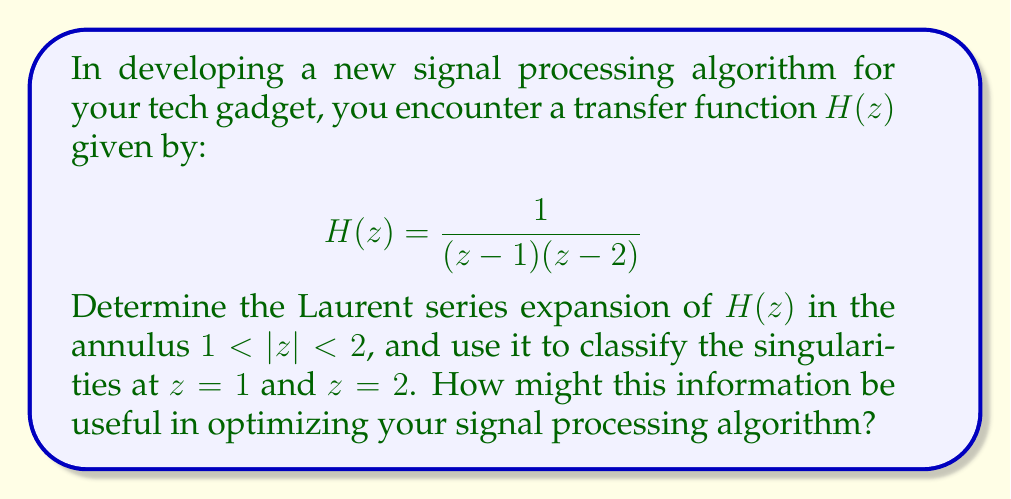Solve this math problem. To solve this problem, we'll follow these steps:

1) First, we need to find the partial fraction decomposition of $H(z)$:

   $$H(z) = \frac{1}{(z-1)(z-2)} = \frac{A}{z-1} + \frac{B}{z-2}$$

   Solving for A and B:
   
   $$A = \lim_{z \to 1} (z-1)H(z) = \frac{1}{1-2} = -1$$
   $$B = \lim_{z \to 2} (z-2)H(z) = \frac{1}{2-1} = 1$$

   So, $H(z) = -\frac{1}{z-1} + \frac{1}{z-2}$

2) Now, we need to expand each term in a Laurent series valid in $1 < |z| < 2$:

   For $-\frac{1}{z-1}$:
   $$-\frac{1}{z-1} = -\frac{1}{z} \cdot \frac{1}{1-\frac{1}{z}} = -\frac{1}{z}(1 + \frac{1}{z} + \frac{1}{z^2} + ...)$$
   $$= -\frac{1}{z} - \frac{1}{z^2} - \frac{1}{z^3} - ...$$

   For $\frac{1}{z-2}$:
   $$\frac{1}{z-2} = -\frac{1}{2} \cdot \frac{1}{1-\frac{z}{2}} = -\frac{1}{2}(1 + \frac{z}{2} + (\frac{z}{2})^2 + ...)$$
   $$= -\frac{1}{2} - \frac{z}{4} - \frac{z^2}{8} - ...$$

3) Combining these series:

   $$H(z) = (-\frac{1}{z} - \frac{1}{z^2} - \frac{1}{z^3} - ...) + (-\frac{1}{2} - \frac{z}{4} - \frac{z^2}{8} - ...)$$

4) Classifying the singularities:

   At $z=1$: The series has negative powers of $z$, indicating a pole.
   At $z=2$: The series has only positive powers of $z$, indicating a removable singularity.

5) Relevance to signal processing:

   In signal processing, poles often correspond to resonances or instabilities in the system. The pole at $z=1$ suggests that the system might have infinite gain at DC (zero frequency), which could lead to instability.

   The removable singularity at $z=2$ doesn't contribute significantly to the system's behavior and could potentially be simplified in the algorithm.

   Understanding these singularities can help in designing filters, predicting system response, and optimizing the algorithm for stability and efficiency.
Answer: The Laurent series expansion of $H(z)$ in $1 < |z| < 2$ is:

$$H(z) = -\frac{1}{z} - \frac{1}{z^2} - \frac{1}{z^3} - ... - \frac{1}{2} - \frac{z}{4} - \frac{z^2}{8} - ...$$

$z=1$ is a simple pole, and $z=2$ is a removable singularity. This information can be used to optimize the signal processing algorithm by addressing potential instability at DC and simplifying the behavior around $z=2$. 